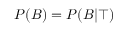Convert formula to latex. <formula><loc_0><loc_0><loc_500><loc_500>P ( B ) = P ( B | \top )</formula> 